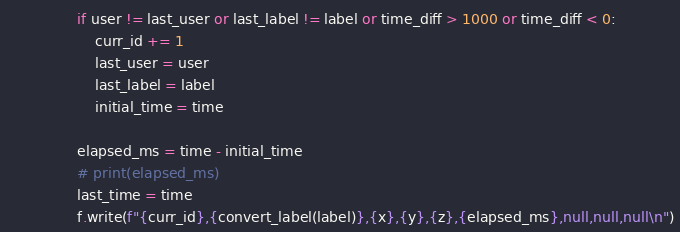Convert code to text. <code><loc_0><loc_0><loc_500><loc_500><_Python_>                if user != last_user or last_label != label or time_diff > 1000 or time_diff < 0:
                    curr_id += 1
                    last_user = user
                    last_label = label
                    initial_time = time

                elapsed_ms = time - initial_time
                # print(elapsed_ms)
                last_time = time
                f.write(f"{curr_id},{convert_label(label)},{x},{y},{z},{elapsed_ms},null,null,null\n")
</code> 